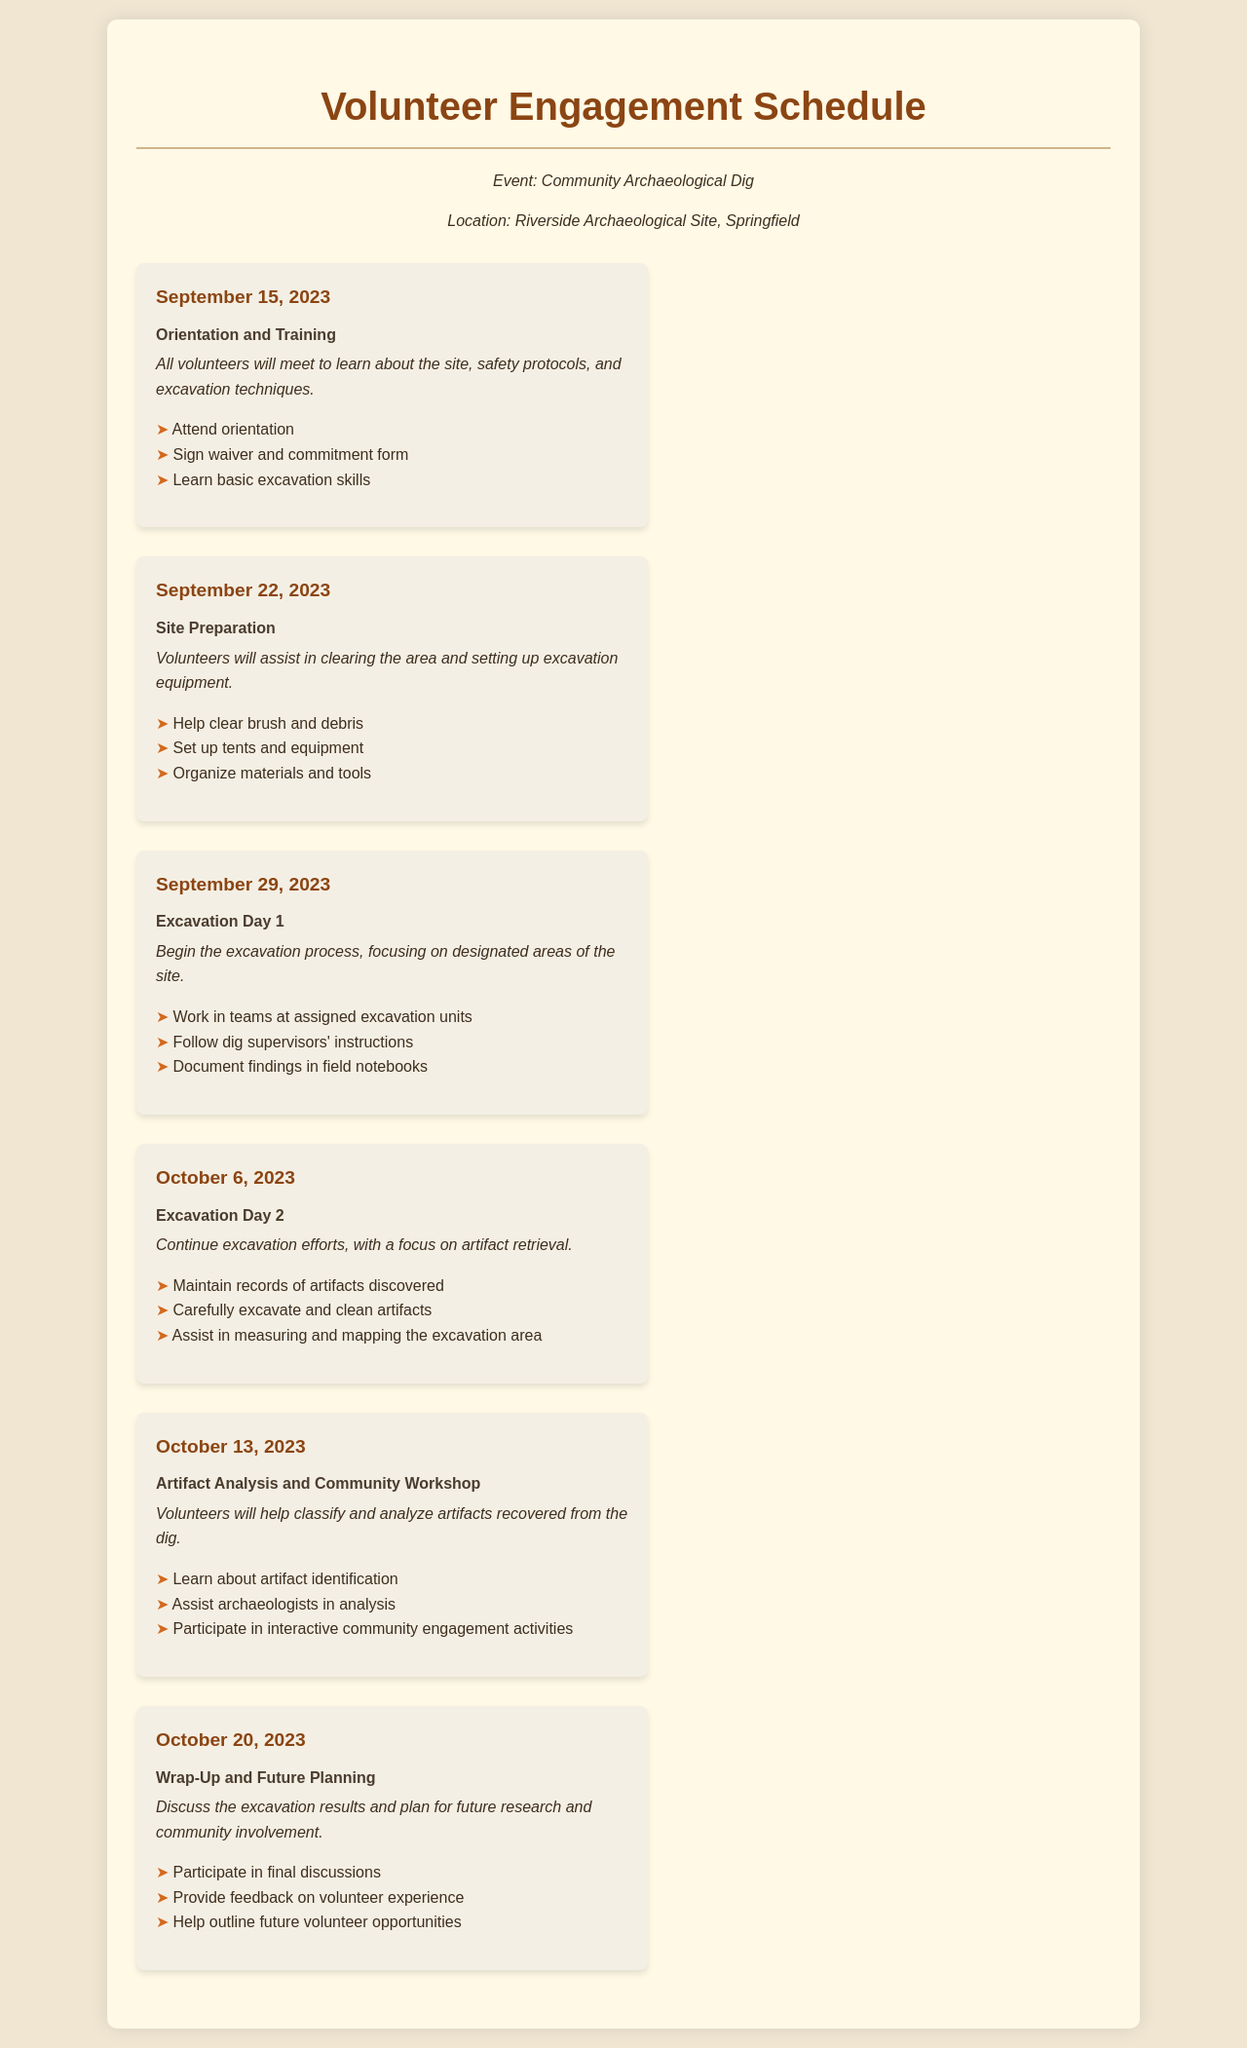what is the first task listed in the schedule? The first task is listed under the date September 15, 2023, which is Orientation and Training.
Answer: Orientation and Training how many excavation days are scheduled? The document lists two excavation days, specifically on September 29, 2023, and October 6, 2023.
Answer: Two who is responsible for documenting findings during Excavation Day 1? The volunteers working in teams at assigned excavation units are responsible for documenting findings in field notebooks.
Answer: Volunteers on which date will volunteers participate in a community workshop? The community workshop is scheduled for October 13, 2023, during the Artifact Analysis and Community Workshop task.
Answer: October 13, 2023 what describes the task for October 20, 2023? The task for that date is to discuss excavation results and plan for future research and community involvement.
Answer: Wrap-Up and Future Planning 